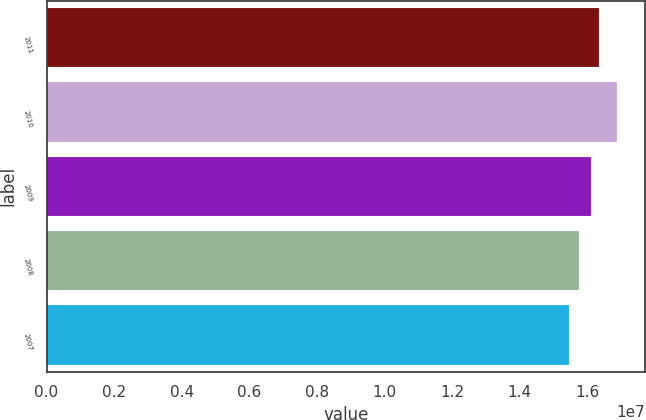Convert chart. <chart><loc_0><loc_0><loc_500><loc_500><bar_chart><fcel>2011<fcel>2010<fcel>2009<fcel>2008<fcel>2007<nl><fcel>1.6347e+07<fcel>1.6866e+07<fcel>1.6107e+07<fcel>1.5755e+07<fcel>1.5463e+07<nl></chart> 